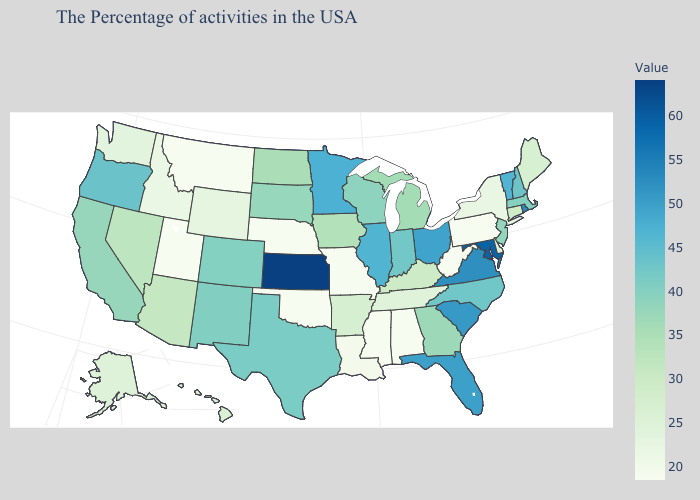Does New Mexico have a higher value than Iowa?
Keep it brief. Yes. Does Florida have a lower value than Maryland?
Write a very short answer. Yes. Among the states that border Idaho , which have the highest value?
Answer briefly. Oregon. Does Kansas have a higher value than Maine?
Be succinct. Yes. Does Kentucky have a higher value than Kansas?
Concise answer only. No. Is the legend a continuous bar?
Write a very short answer. Yes. Is the legend a continuous bar?
Write a very short answer. Yes. 